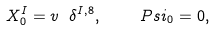<formula> <loc_0><loc_0><loc_500><loc_500>X _ { 0 } ^ { I } = v \ \delta ^ { I , 8 } , \ \quad P s i _ { 0 } = 0 ,</formula> 